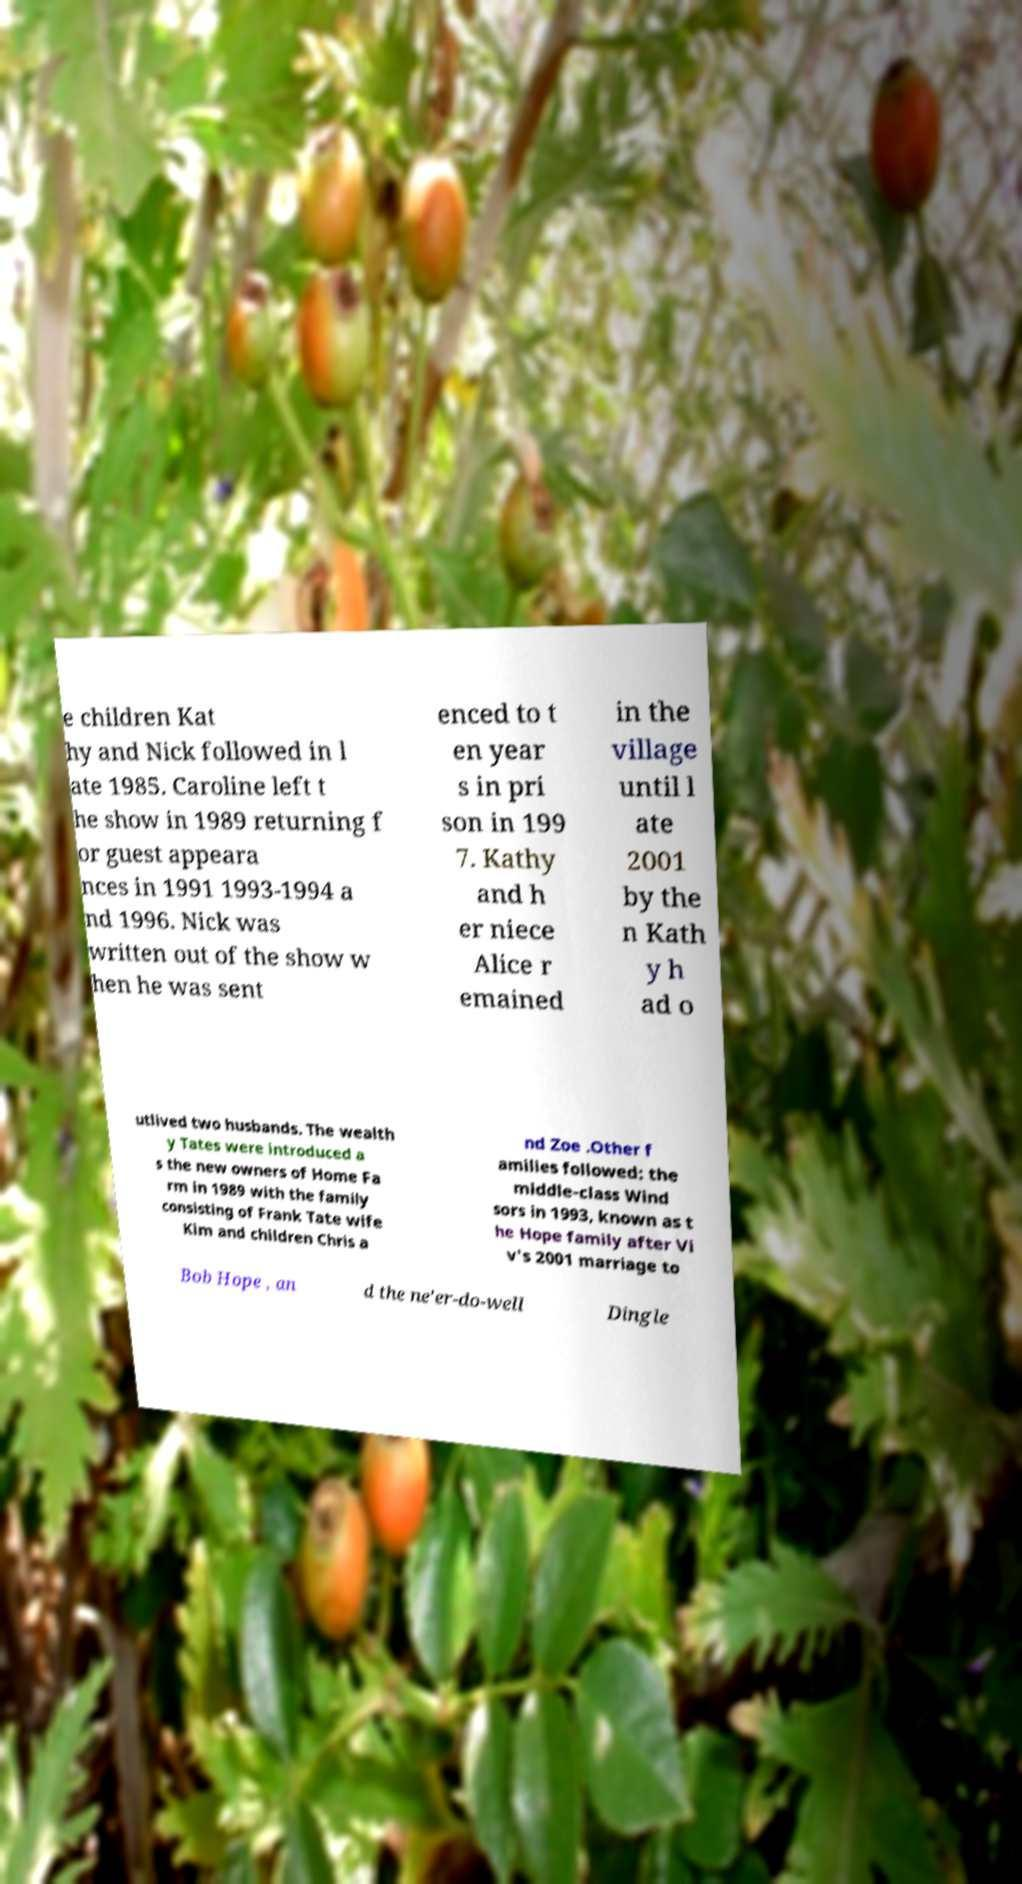Could you extract and type out the text from this image? e children Kat hy and Nick followed in l ate 1985. Caroline left t he show in 1989 returning f or guest appeara nces in 1991 1993-1994 a nd 1996. Nick was written out of the show w hen he was sent enced to t en year s in pri son in 199 7. Kathy and h er niece Alice r emained in the village until l ate 2001 by the n Kath y h ad o utlived two husbands. The wealth y Tates were introduced a s the new owners of Home Fa rm in 1989 with the family consisting of Frank Tate wife Kim and children Chris a nd Zoe .Other f amilies followed: the middle-class Wind sors in 1993, known as t he Hope family after Vi v's 2001 marriage to Bob Hope , an d the ne'er-do-well Dingle 